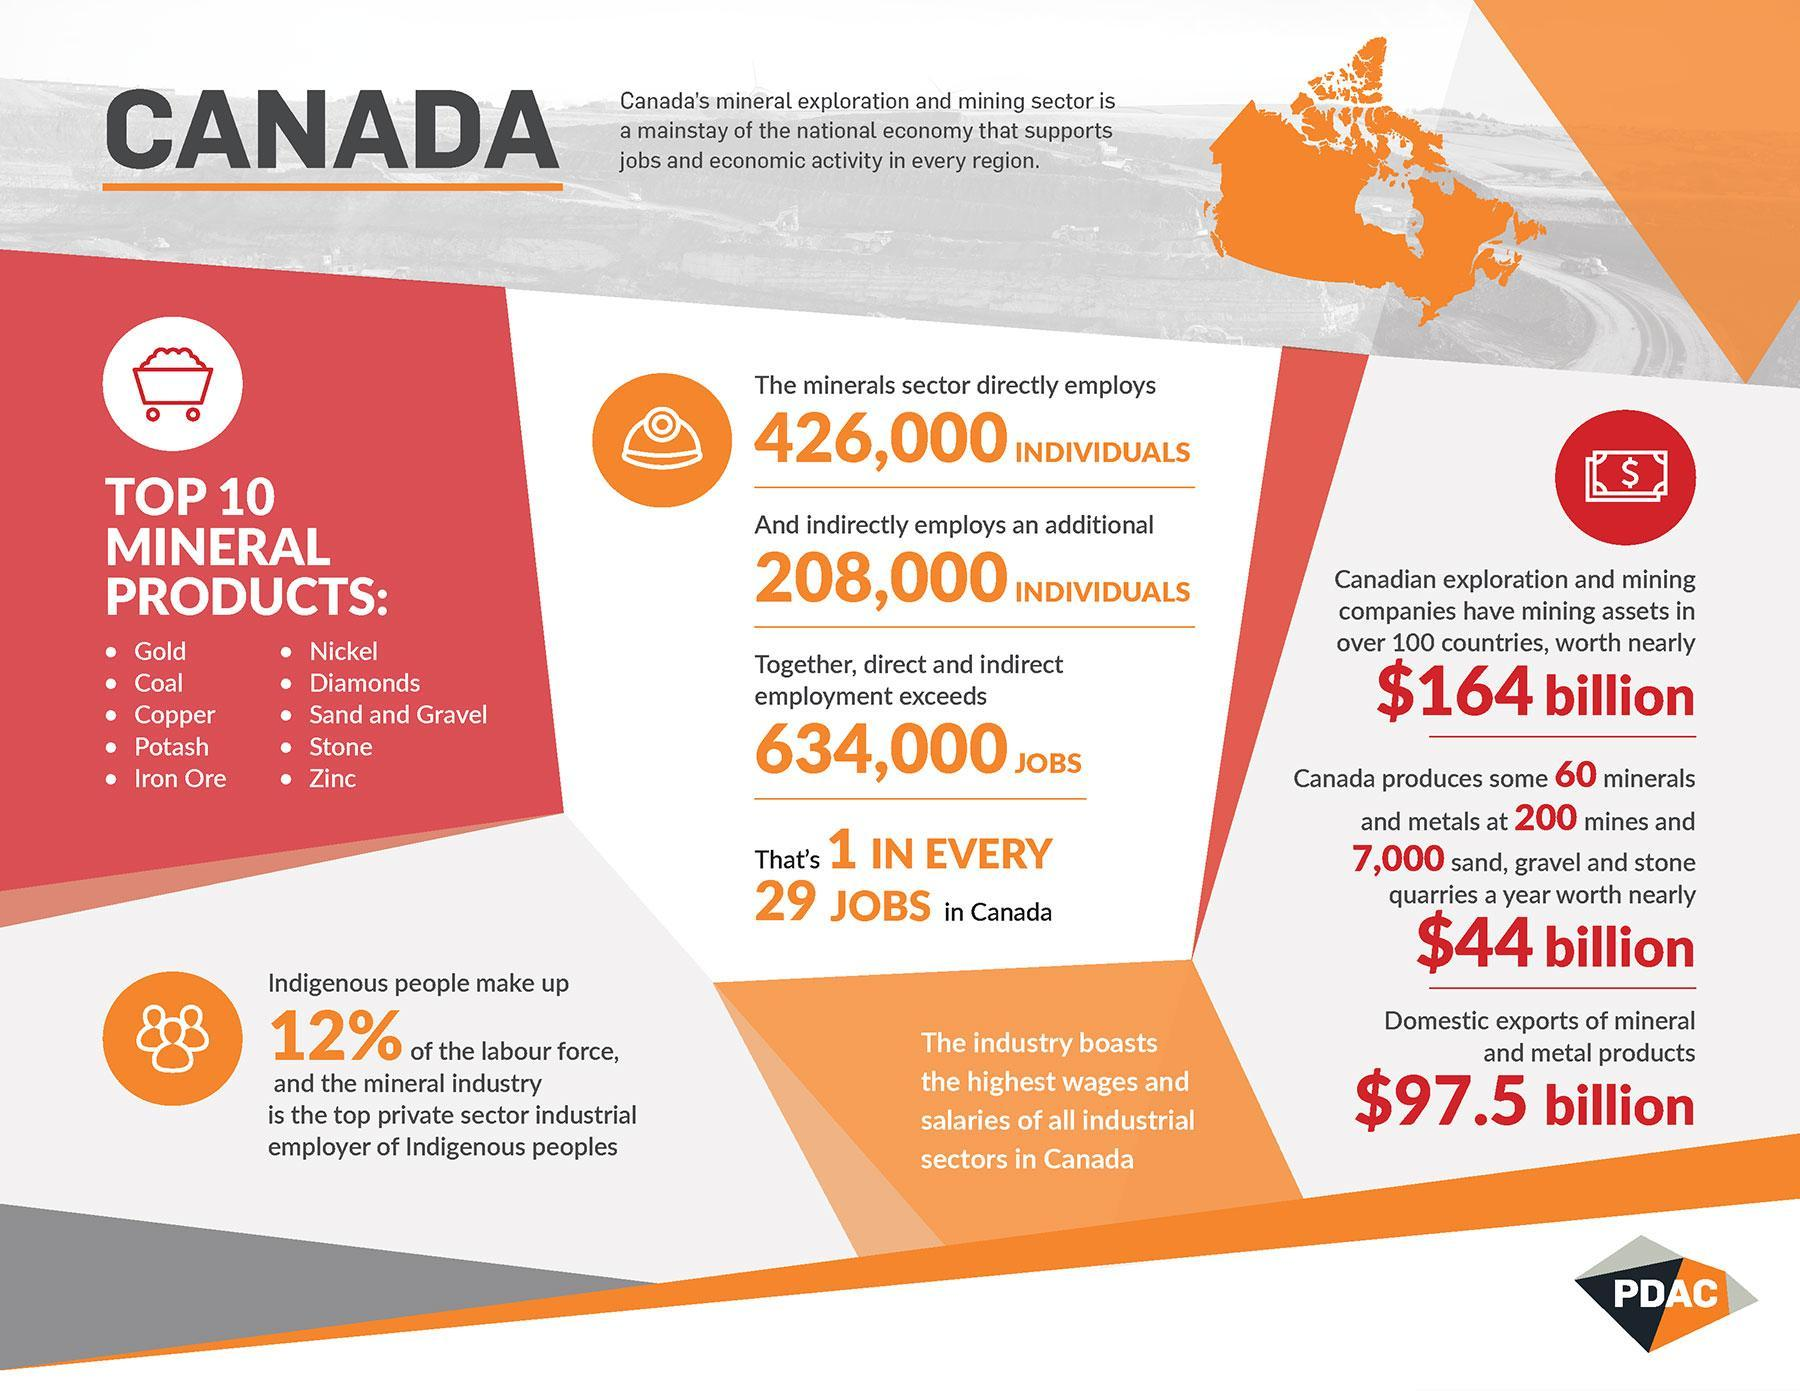which industry boasts of highest wages and salaries
Answer the question with a short phrase. mineral What is the total yearly worth of all minerals, metals, sand, gravel and stone produced by Canada $44 billion what is the total count of individuals employed directly and indirectly by the mineral sector 634000 WHich are the top 10 minerals that start with alphabet C Coal,Copper How many indirect employment by the mineral sector 208,000 What is the sign on the currency logo $ 